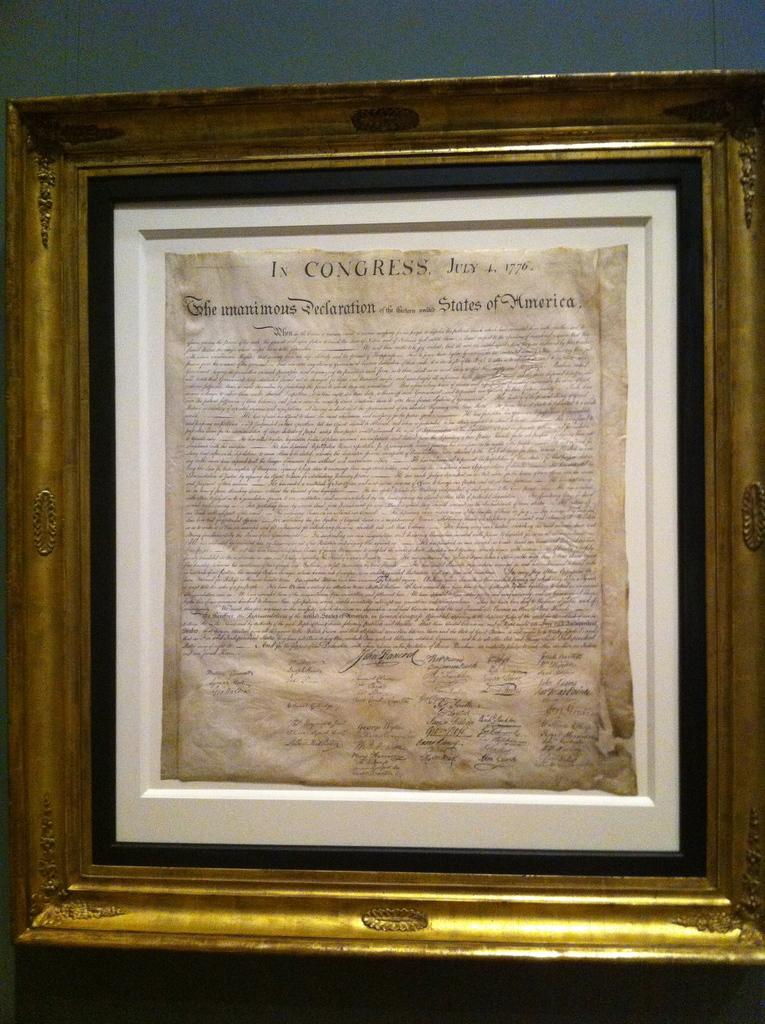Provide a one-sentence caption for the provided image. The declaration of the Independence in a white frame which is located inside a bigger black and gold frame. 